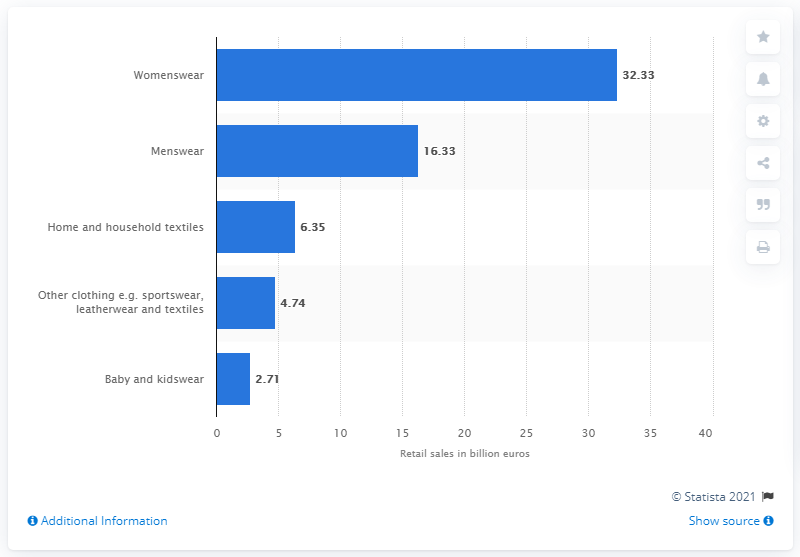Draw attention to some important aspects in this diagram. In 2014, the total sales of women's clothing in Germany were 32.33 billion euros. 